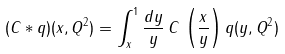Convert formula to latex. <formula><loc_0><loc_0><loc_500><loc_500>( C * q ) ( x , Q ^ { 2 } ) = \int _ { x } ^ { 1 } \frac { d y } { y } \, C \, \left ( \frac { x } { y } \right ) q ( y , Q ^ { 2 } )</formula> 